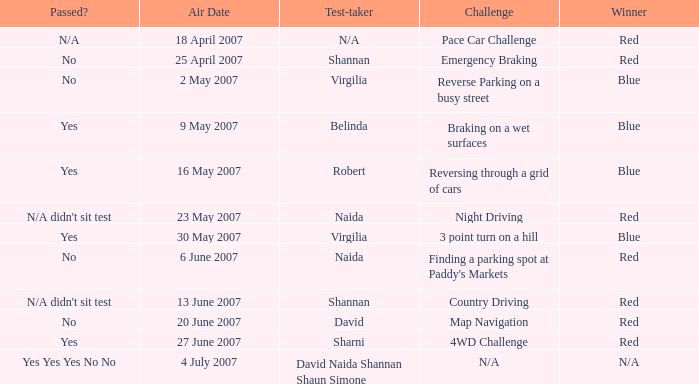On which air date was Robert the test-taker? 16 May 2007. 